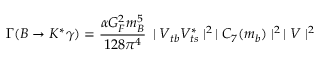Convert formula to latex. <formula><loc_0><loc_0><loc_500><loc_500>\Gamma ( B \rightarrow K ^ { * } \gamma ) = \frac { \alpha G _ { F } ^ { 2 } m _ { B } ^ { 5 } } { 1 2 8 \pi ^ { 4 } } \, | V _ { t b } V _ { t s } ^ { * } | ^ { 2 } \, | C _ { 7 } ( m _ { b } ) | ^ { 2 } \, | V | ^ { 2 }</formula> 